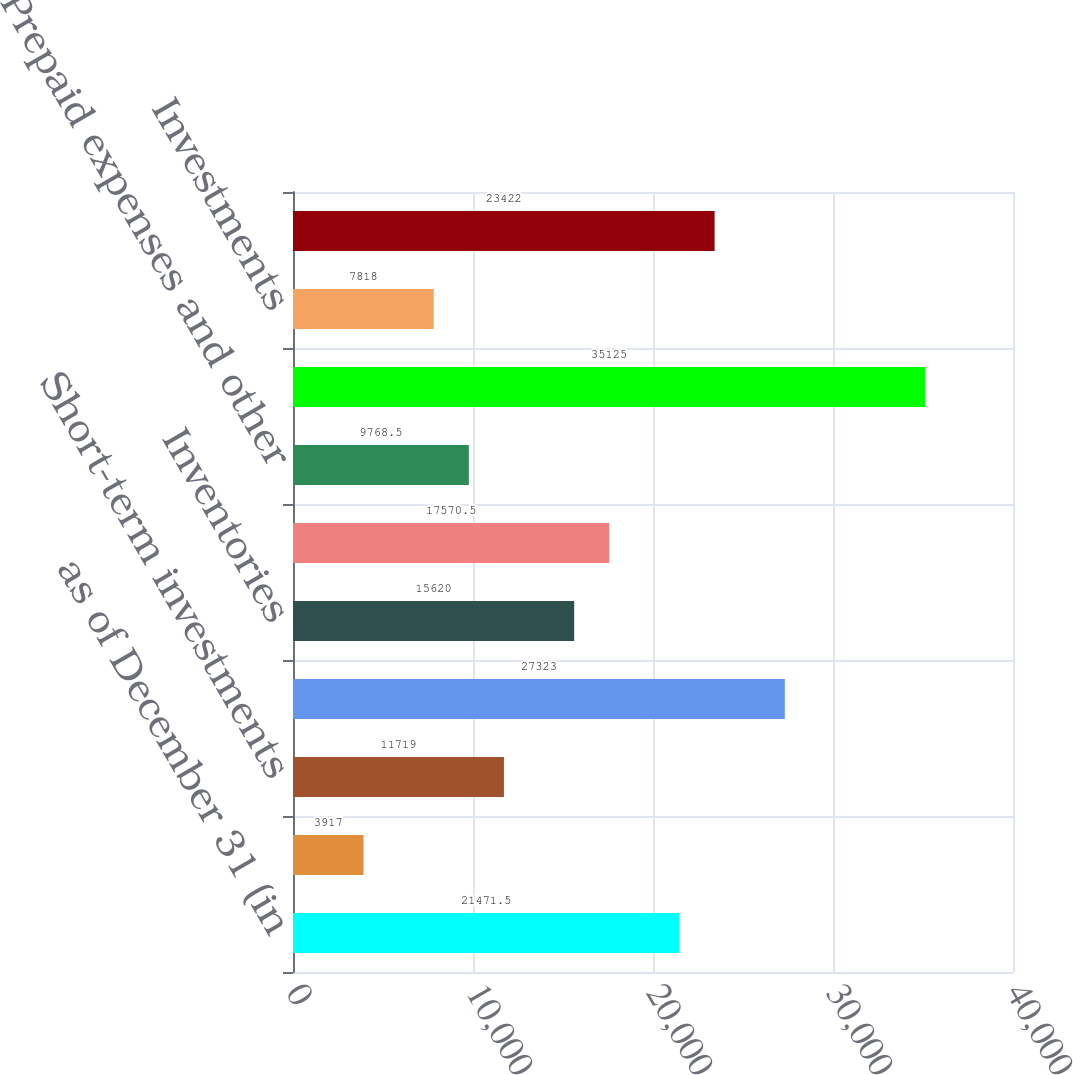Convert chart. <chart><loc_0><loc_0><loc_500><loc_500><bar_chart><fcel>as of December 31 (in<fcel>Cash and equivalents<fcel>Short-term investments<fcel>Accounts receivable<fcel>Inventories<fcel>Deferred income taxes<fcel>Prepaid expenses and other<fcel>Total current assets<fcel>Investments<fcel>Net property and equipment<nl><fcel>21471.5<fcel>3917<fcel>11719<fcel>27323<fcel>15620<fcel>17570.5<fcel>9768.5<fcel>35125<fcel>7818<fcel>23422<nl></chart> 